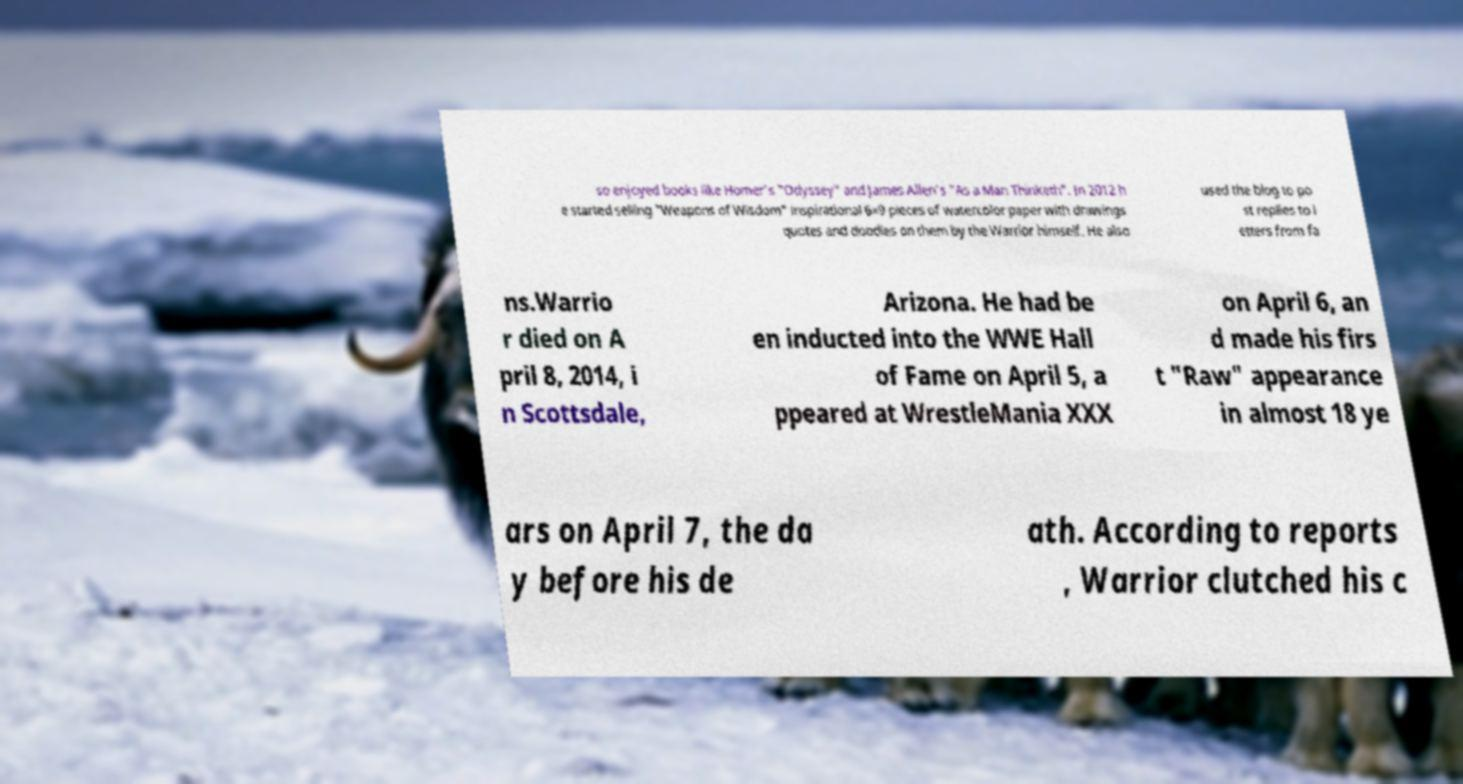Can you accurately transcribe the text from the provided image for me? so enjoyed books like Homer's "Odyssey" and James Allen's "As a Man Thinketh". In 2012 h e started selling "Weapons of Wisdom" inspirational 6×9 pieces of watercolor paper with drawings quotes and doodles on them by the Warrior himself. He also used the blog to po st replies to l etters from fa ns.Warrio r died on A pril 8, 2014, i n Scottsdale, Arizona. He had be en inducted into the WWE Hall of Fame on April 5, a ppeared at WrestleMania XXX on April 6, an d made his firs t "Raw" appearance in almost 18 ye ars on April 7, the da y before his de ath. According to reports , Warrior clutched his c 